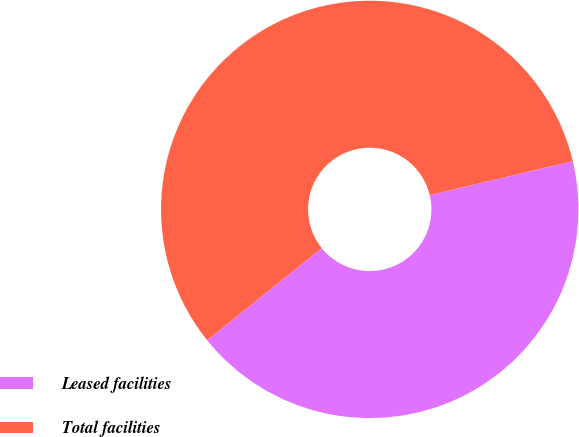<chart> <loc_0><loc_0><loc_500><loc_500><pie_chart><fcel>Leased facilities<fcel>Total facilities<nl><fcel>42.93%<fcel>57.07%<nl></chart> 